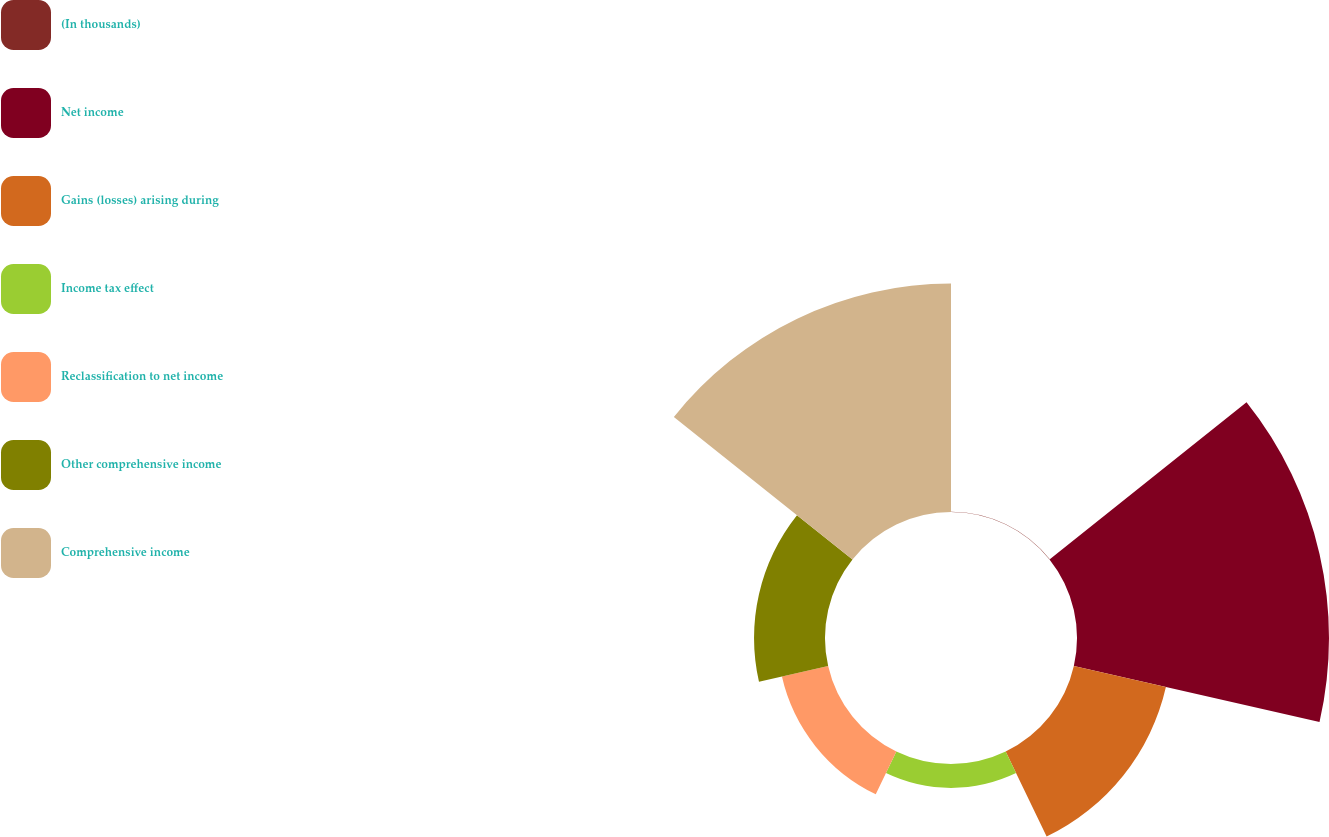Convert chart to OTSL. <chart><loc_0><loc_0><loc_500><loc_500><pie_chart><fcel>(In thousands)<fcel>Net income<fcel>Gains (losses) arising during<fcel>Income tax effect<fcel>Reclassification to net income<fcel>Other comprehensive income<fcel>Comprehensive income<nl><fcel>0.05%<fcel>35.12%<fcel>13.16%<fcel>3.33%<fcel>6.61%<fcel>9.89%<fcel>31.84%<nl></chart> 